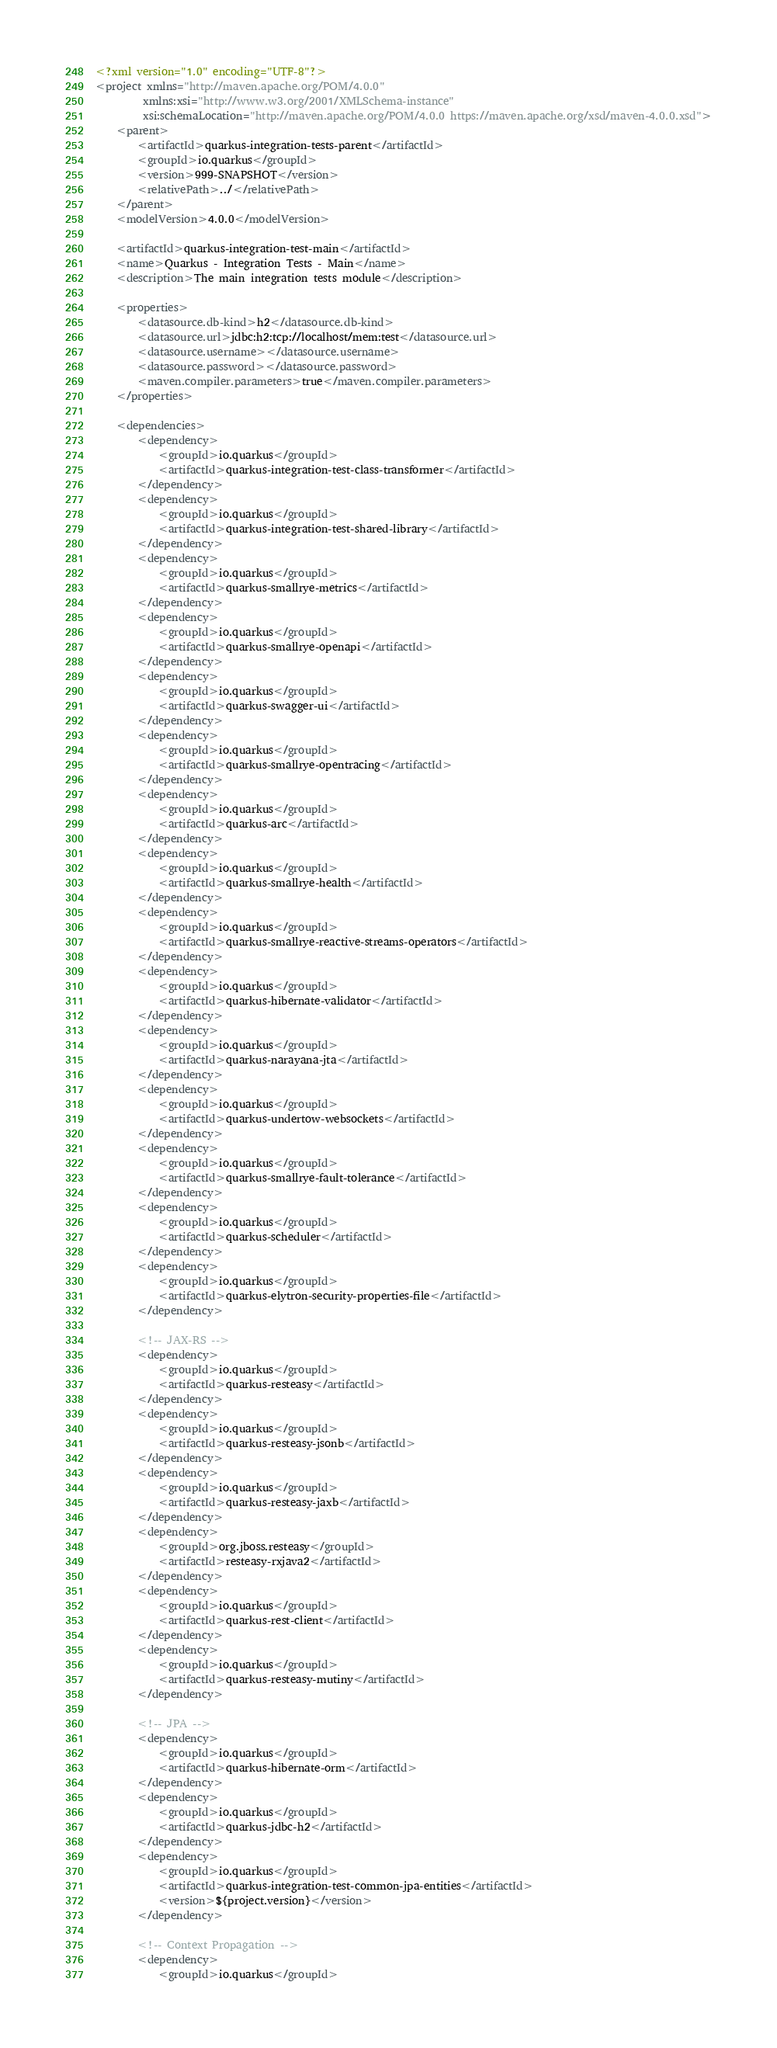<code> <loc_0><loc_0><loc_500><loc_500><_XML_><?xml version="1.0" encoding="UTF-8"?>
<project xmlns="http://maven.apache.org/POM/4.0.0"
         xmlns:xsi="http://www.w3.org/2001/XMLSchema-instance"
         xsi:schemaLocation="http://maven.apache.org/POM/4.0.0 https://maven.apache.org/xsd/maven-4.0.0.xsd">
    <parent>
        <artifactId>quarkus-integration-tests-parent</artifactId>
        <groupId>io.quarkus</groupId>
        <version>999-SNAPSHOT</version>
        <relativePath>../</relativePath>
    </parent>
    <modelVersion>4.0.0</modelVersion>

    <artifactId>quarkus-integration-test-main</artifactId>
    <name>Quarkus - Integration Tests - Main</name>
    <description>The main integration tests module</description>

    <properties>
        <datasource.db-kind>h2</datasource.db-kind>
        <datasource.url>jdbc:h2:tcp://localhost/mem:test</datasource.url>
        <datasource.username></datasource.username>
        <datasource.password></datasource.password>
        <maven.compiler.parameters>true</maven.compiler.parameters>
    </properties>

    <dependencies>
        <dependency>
            <groupId>io.quarkus</groupId>
            <artifactId>quarkus-integration-test-class-transformer</artifactId>
        </dependency>
        <dependency>
            <groupId>io.quarkus</groupId>
            <artifactId>quarkus-integration-test-shared-library</artifactId>
        </dependency>
        <dependency>
            <groupId>io.quarkus</groupId>
            <artifactId>quarkus-smallrye-metrics</artifactId>
        </dependency>
        <dependency>
            <groupId>io.quarkus</groupId>
            <artifactId>quarkus-smallrye-openapi</artifactId>
        </dependency>
        <dependency>
            <groupId>io.quarkus</groupId>
            <artifactId>quarkus-swagger-ui</artifactId>
        </dependency>
        <dependency>
            <groupId>io.quarkus</groupId>
            <artifactId>quarkus-smallrye-opentracing</artifactId>
        </dependency>
        <dependency>
            <groupId>io.quarkus</groupId>
            <artifactId>quarkus-arc</artifactId>
        </dependency>
        <dependency>
            <groupId>io.quarkus</groupId>
            <artifactId>quarkus-smallrye-health</artifactId>
        </dependency>
        <dependency>
            <groupId>io.quarkus</groupId>
            <artifactId>quarkus-smallrye-reactive-streams-operators</artifactId>
        </dependency>
        <dependency>
            <groupId>io.quarkus</groupId>
            <artifactId>quarkus-hibernate-validator</artifactId>
        </dependency>
        <dependency>
            <groupId>io.quarkus</groupId>
            <artifactId>quarkus-narayana-jta</artifactId>
        </dependency>
        <dependency>
            <groupId>io.quarkus</groupId>
            <artifactId>quarkus-undertow-websockets</artifactId>
        </dependency>
        <dependency>
            <groupId>io.quarkus</groupId>
            <artifactId>quarkus-smallrye-fault-tolerance</artifactId>
        </dependency>
        <dependency>
            <groupId>io.quarkus</groupId>
            <artifactId>quarkus-scheduler</artifactId>
        </dependency>
        <dependency>
            <groupId>io.quarkus</groupId>
            <artifactId>quarkus-elytron-security-properties-file</artifactId>
        </dependency>

        <!-- JAX-RS -->
        <dependency>
            <groupId>io.quarkus</groupId>
            <artifactId>quarkus-resteasy</artifactId>
        </dependency>
        <dependency>
            <groupId>io.quarkus</groupId>
            <artifactId>quarkus-resteasy-jsonb</artifactId>
        </dependency>
        <dependency>
            <groupId>io.quarkus</groupId>
            <artifactId>quarkus-resteasy-jaxb</artifactId>
        </dependency>
        <dependency>
            <groupId>org.jboss.resteasy</groupId>
            <artifactId>resteasy-rxjava2</artifactId>
        </dependency>
        <dependency>
            <groupId>io.quarkus</groupId>
            <artifactId>quarkus-rest-client</artifactId>
        </dependency>
        <dependency>
            <groupId>io.quarkus</groupId>
            <artifactId>quarkus-resteasy-mutiny</artifactId>
        </dependency>

        <!-- JPA -->
        <dependency>
            <groupId>io.quarkus</groupId>
            <artifactId>quarkus-hibernate-orm</artifactId>
        </dependency>
        <dependency>
            <groupId>io.quarkus</groupId>
            <artifactId>quarkus-jdbc-h2</artifactId>
        </dependency>
        <dependency>
            <groupId>io.quarkus</groupId>
            <artifactId>quarkus-integration-test-common-jpa-entities</artifactId>
            <version>${project.version}</version>
        </dependency>

        <!-- Context Propagation -->
        <dependency>
            <groupId>io.quarkus</groupId></code> 